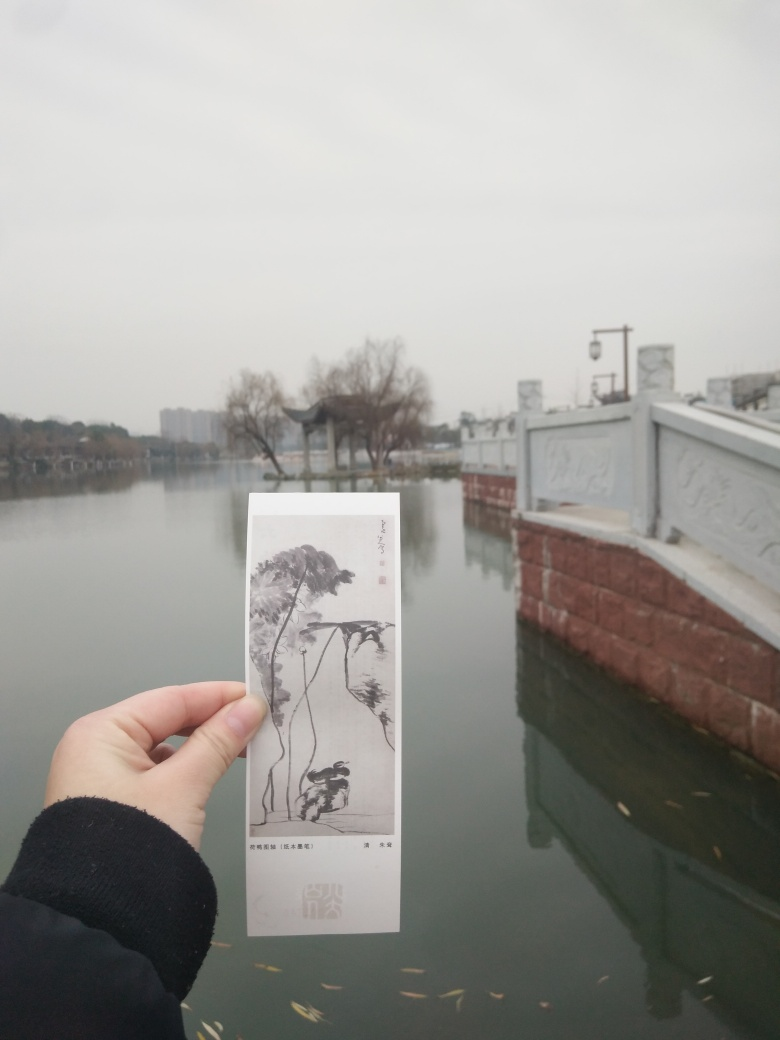Is there a cultural or historical significance to the location depicted in the image? While the specific location is not disclosed, the style of the bridge and the calm waterway suggest an East Asian setting, possibly China, where such traditional architecture is prevalent. This type of setting often holds cultural and historical importance, being common in regions with rich heritage and where such waterways are integral to the local landscape and way of life. 